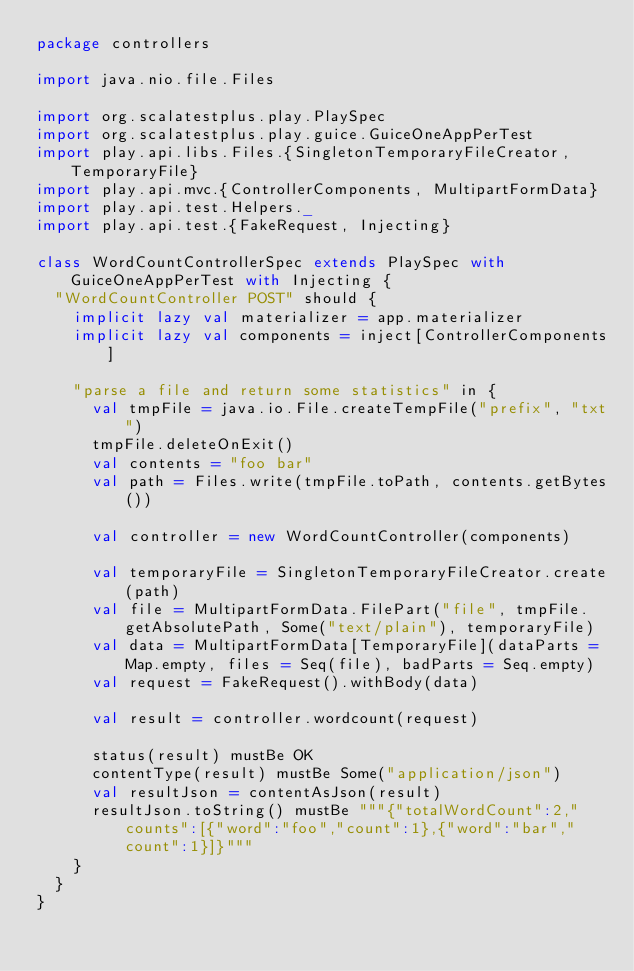Convert code to text. <code><loc_0><loc_0><loc_500><loc_500><_Scala_>package controllers

import java.nio.file.Files

import org.scalatestplus.play.PlaySpec
import org.scalatestplus.play.guice.GuiceOneAppPerTest
import play.api.libs.Files.{SingletonTemporaryFileCreator, TemporaryFile}
import play.api.mvc.{ControllerComponents, MultipartFormData}
import play.api.test.Helpers._
import play.api.test.{FakeRequest, Injecting}

class WordCountControllerSpec extends PlaySpec with GuiceOneAppPerTest with Injecting {
  "WordCountController POST" should {
    implicit lazy val materializer = app.materializer
    implicit lazy val components = inject[ControllerComponents]

    "parse a file and return some statistics" in {
      val tmpFile = java.io.File.createTempFile("prefix", "txt")
      tmpFile.deleteOnExit()
      val contents = "foo bar"
      val path = Files.write(tmpFile.toPath, contents.getBytes())

      val controller = new WordCountController(components)

      val temporaryFile = SingletonTemporaryFileCreator.create(path)
      val file = MultipartFormData.FilePart("file", tmpFile.getAbsolutePath, Some("text/plain"), temporaryFile)
      val data = MultipartFormData[TemporaryFile](dataParts = Map.empty, files = Seq(file), badParts = Seq.empty)
      val request = FakeRequest().withBody(data)

      val result = controller.wordcount(request)

      status(result) mustBe OK
      contentType(result) mustBe Some("application/json")
      val resultJson = contentAsJson(result)
      resultJson.toString() mustBe """{"totalWordCount":2,"counts":[{"word":"foo","count":1},{"word":"bar","count":1}]}"""
    }
  }
}
</code> 